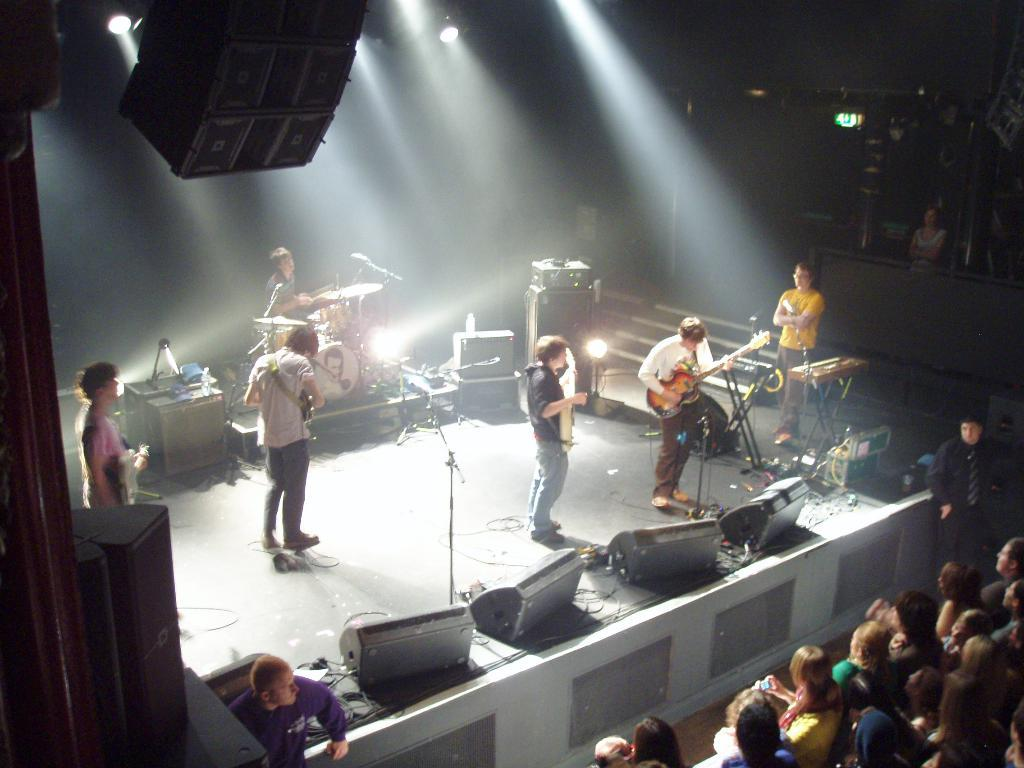How many people are in the image? There are people in the image, but the exact number is not specified. What are the people in the image doing? Some people are standing, while others are sitting. What can be seen on the stage in the image? People on the stage are holding guitars. What is the tendency of the heat in the image? There is no mention of heat or temperature in the image, so it is not possible to determine any tendency. 